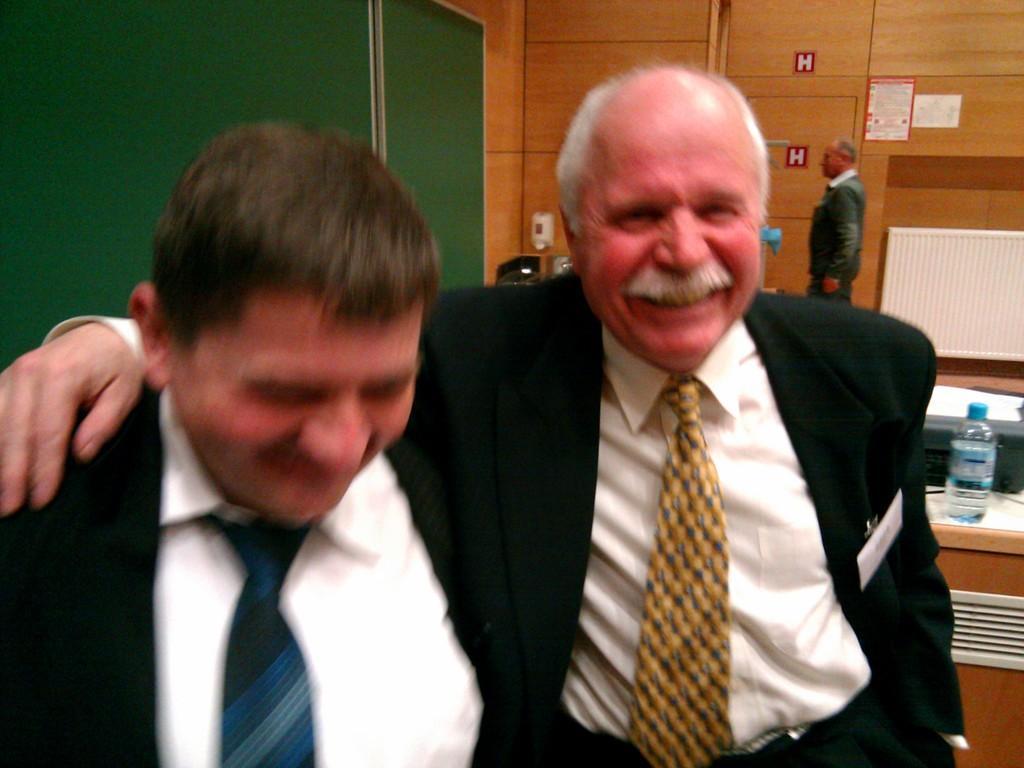Can you describe this image briefly? In this image I can see two persons wearing white shirts and black blazers. In the background I can see a desk on which I can see a water bottle and few other objects, a green colored board, a person standing and the orange colored surface and few posts attached to the surface. 